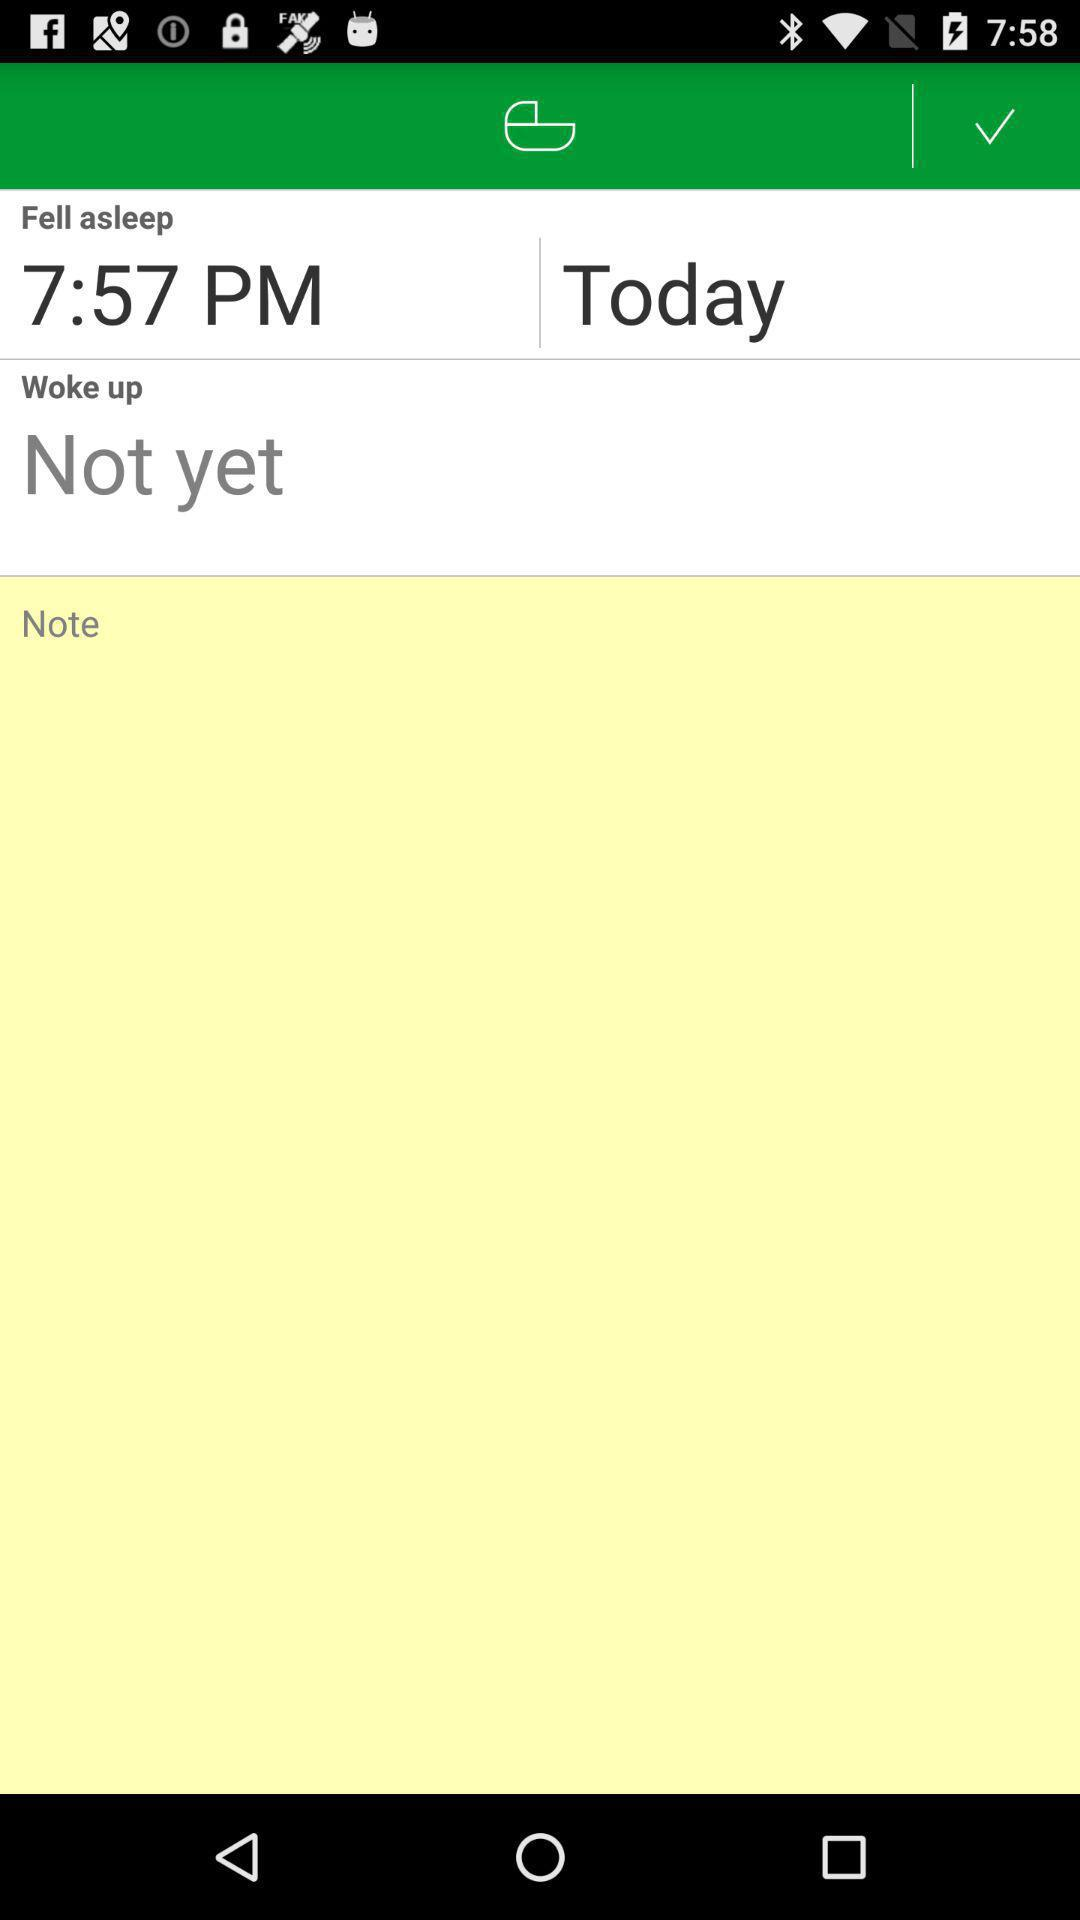What is mentioned in "Woke up"? In "Woke up", "Not yet" is mentioned. 